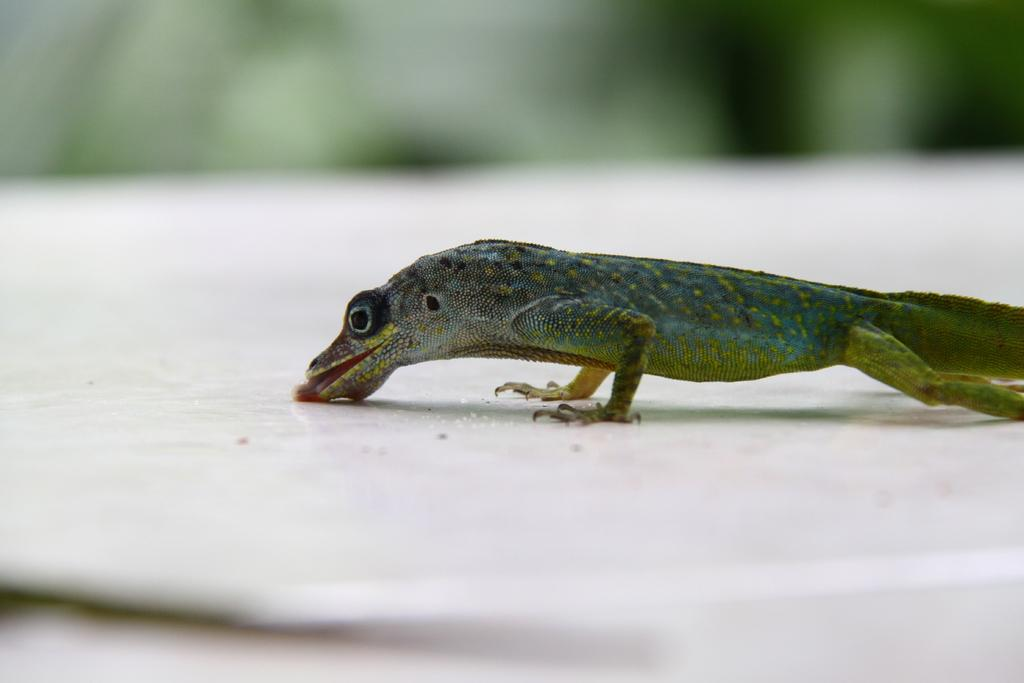What type of animal is present in the image? There is a green color reptile in the image. What type of destruction is the snake causing in the image? There is no snake present in the image, and therefore no destruction can be observed. 